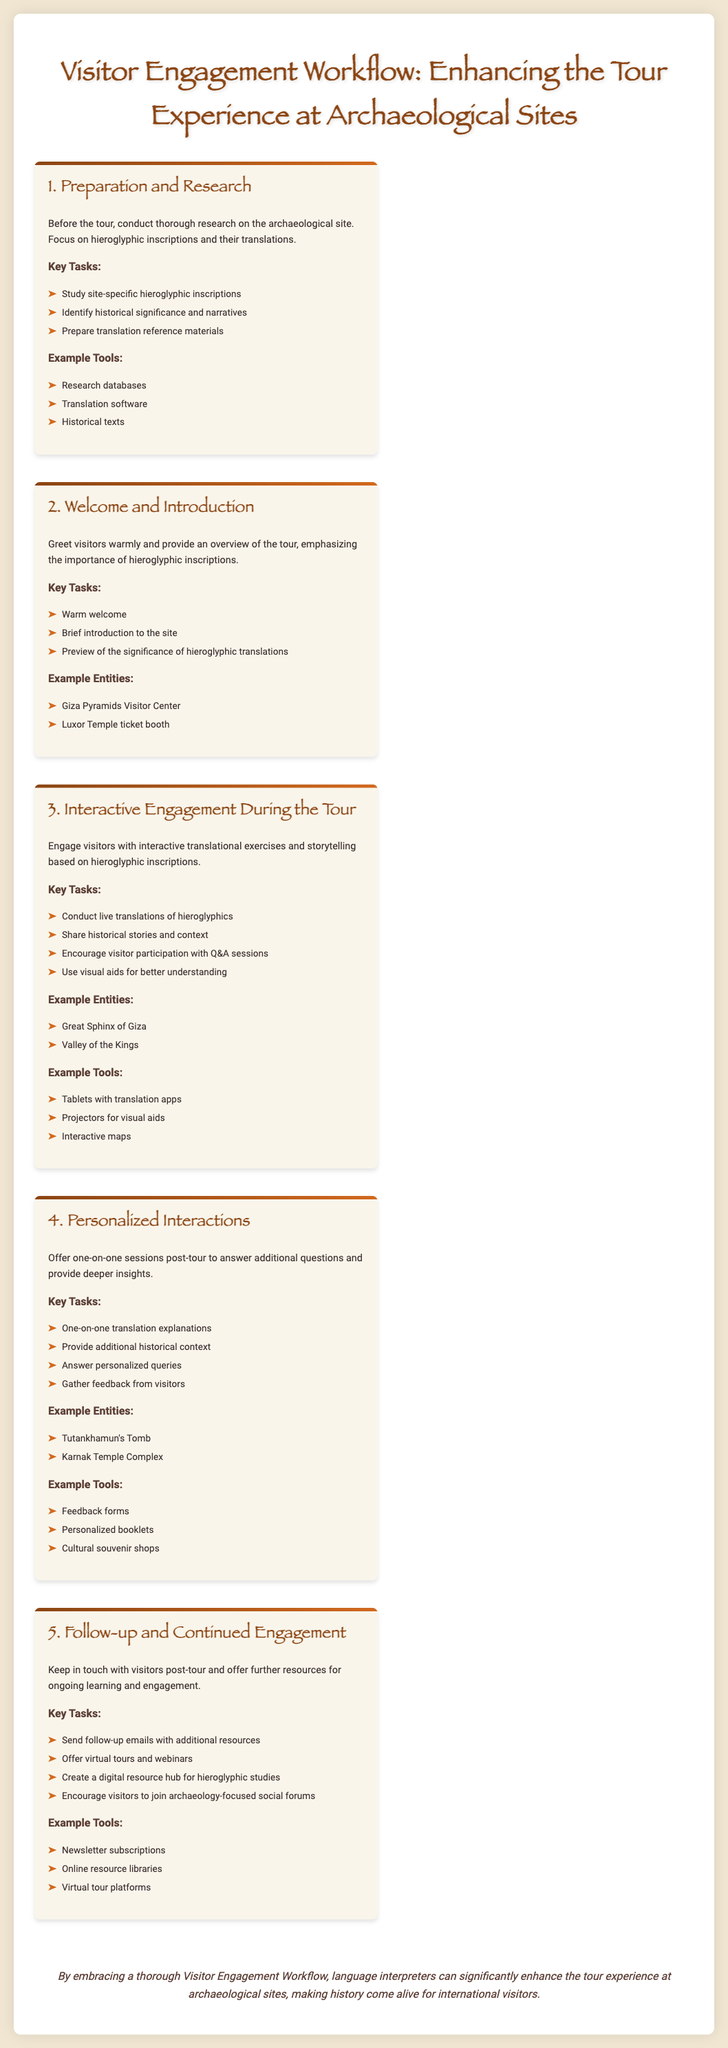What is the first step in the Visitor Engagement Workflow? The first step outlined in the document is "Preparation and Research".
Answer: Preparation and Research What is one of the key tasks during the "Welcome and Introduction"? The document lists "Brief introduction to the site" as a key task during this step.
Answer: Brief introduction to the site What example tool is mentioned in the "Interactive Engagement During the Tour"? The document mentions "Tablets with translation apps" as an example tool.
Answer: Tablets with translation apps What specific type of interactions are suggested in the fourth step? The document specifies "one-on-one sessions post-tour" as the type of interactions in this step.
Answer: one-on-one sessions post-tour What does the final step encourage for continued learning? The document suggests "encourage visitors to join archaeology-focused social forums" for continued learning.
Answer: encourage visitors to join archaeology-focused social forums How many example entities are listed under "Interactive Engagement During the Tour"? The document lists two example entities under this section, which requires counting them.
Answer: 2 What is the color theme used in the document? The document primarily uses earthy tones, specifically mentioning shades like #8B4513 and #D2691E.
Answer: earthy tones Which section includes "Feedback forms"? The section "Personalized Interactions" includes "Feedback forms".
Answer: Personalized Interactions What is the overarching goal of the Visitor Engagement Workflow? The document states the goal is to "enhance the tour experience at archaeological sites".
Answer: enhance the tour experience at archaeological sites 